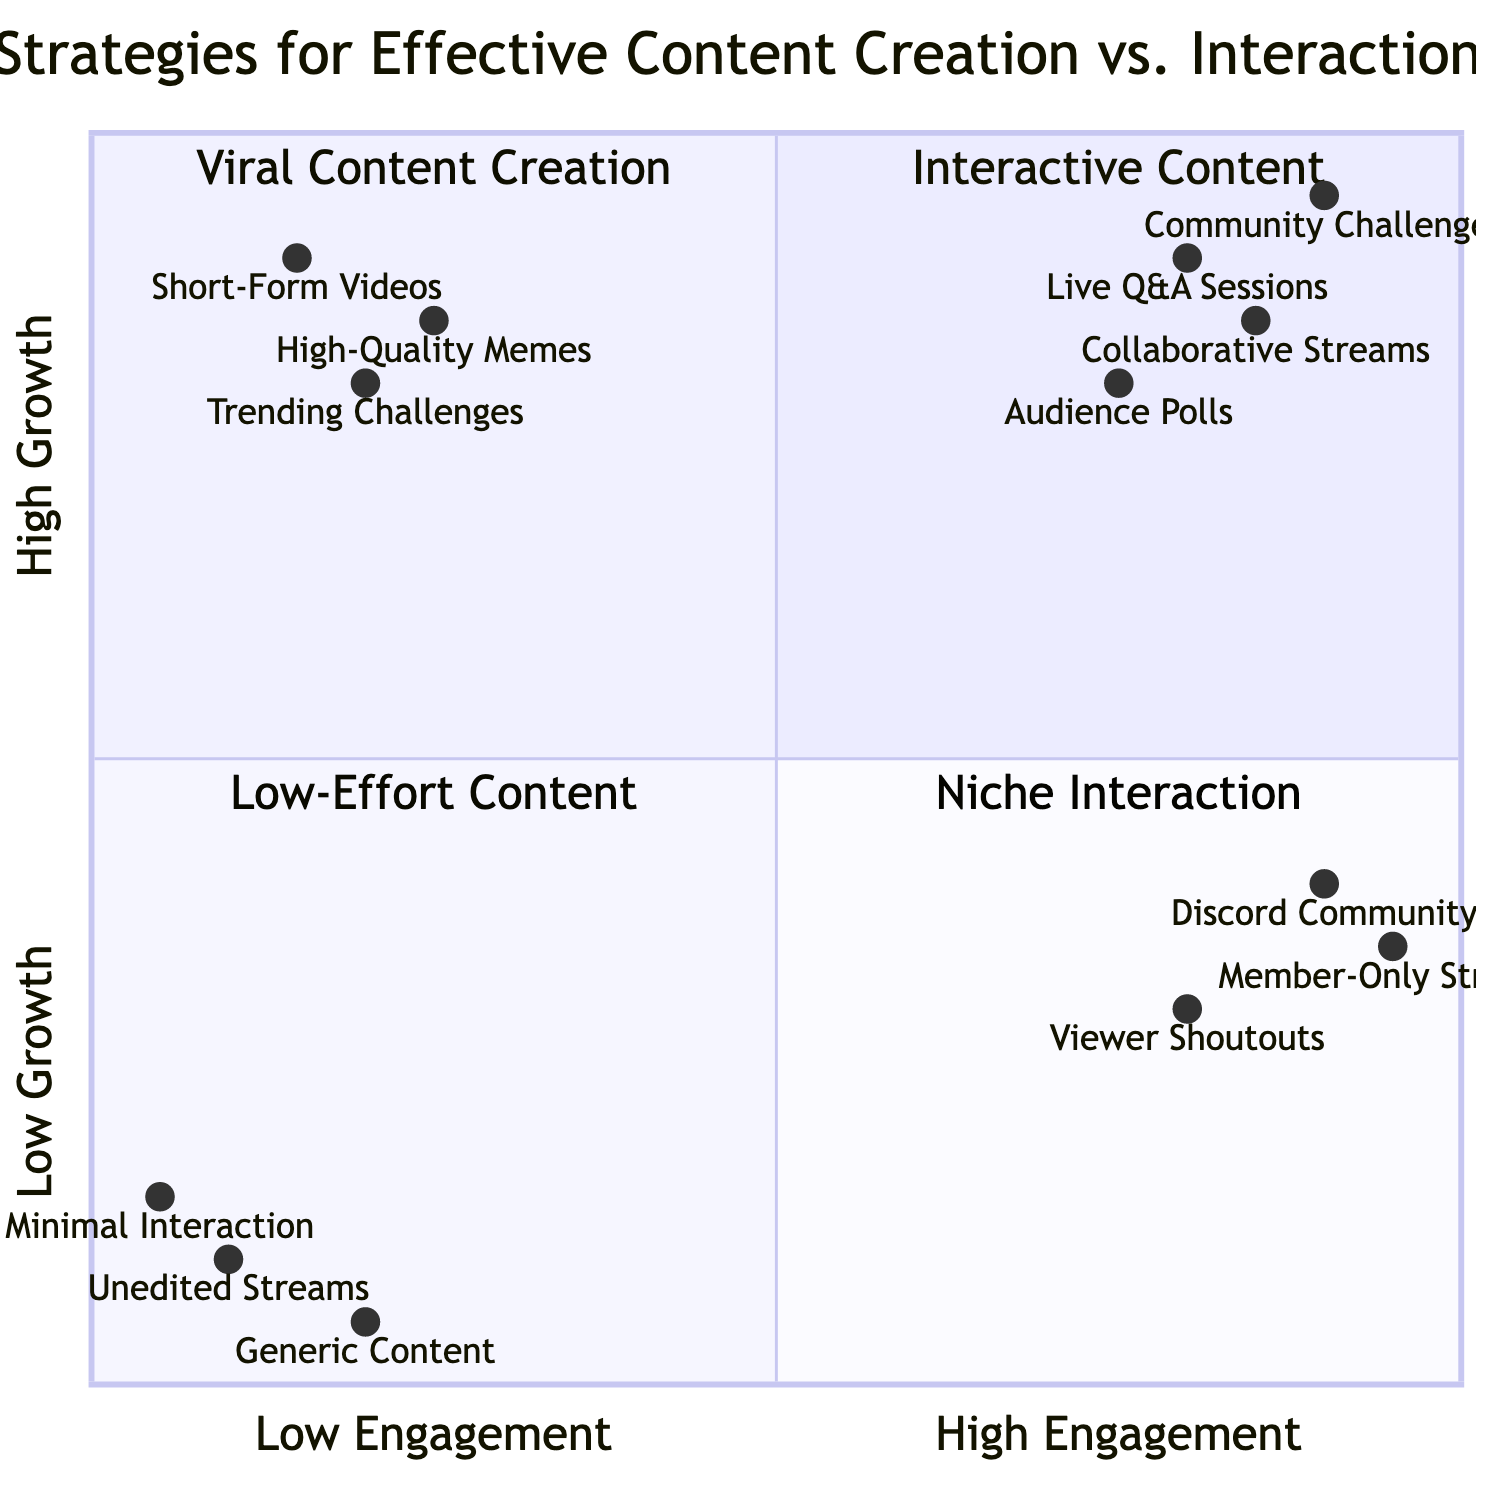What strategy is in the High Engagement, High Growth quadrant? In the quadrant labeled "High Engagement, High Growth," the strategy mentioned is "Interactive Content." This can be found by looking specifically at that section of the diagram.
Answer: Interactive Content Which quadrant contains Niche Interaction? Niche Interaction is located in the quadrant labeled "High Engagement, Low Growth." This is a distinct area of the chart that can be identified by its position.
Answer: High Engagement, Low Growth How many examples are provided for Viral Content Creation? The quadrant for "Viral Content Creation" lists three specific examples: "Trending Topics and Challenges," "Short-Form Viral Videos," and "High-Quality Memes." By counting these examples, we see there are three.
Answer: 3 Which content strategy has the lowest engagement and growth? The quadrant designated for "Low Engagement, Low Growth" identifies "Low-Effort Content" as the strategy, which directly indicates the least engagement and growth.
Answer: Low-Effort Content What type of content is recommended for high growth but low engagement? The content recommended for high growth but low engagement is identified within the "Low Engagement, High Growth" quadrant as "Viral Content Creation." This classification is clear within that segment of the diagram.
Answer: Viral Content Creation Which strategy has the highest engagement score from the examples listed? By examining the examples under "Interactive Content," "Community Challenges" shows the highest engagement score of 0.9, which indicates its effectiveness in engaging the audience.
Answer: Community Challenges What is the primary real-world entity associated with Discord Community? The real-world entity associated with "Discord Community" is "Discord Daily Interactions," which links the strategy to a specific platform that enhances community engagement.
Answer: Discord Daily Interactions Which quadrant includes automated gameplay streams? Automated gameplay streams are associated with the "Low Engagement, Low Growth" quadrant, where "Low-Effort Content" is the overall strategy that describes this kind of content.
Answer: Low Engagement, Low Growth How many total strategies are presented in the diagram? By analyzing the quadrants, there are four distinct strategies: Interactive Content, Niche Interaction, Viral Content Creation, and Low-Effort Content, totaling to four strategies.
Answer: 4 